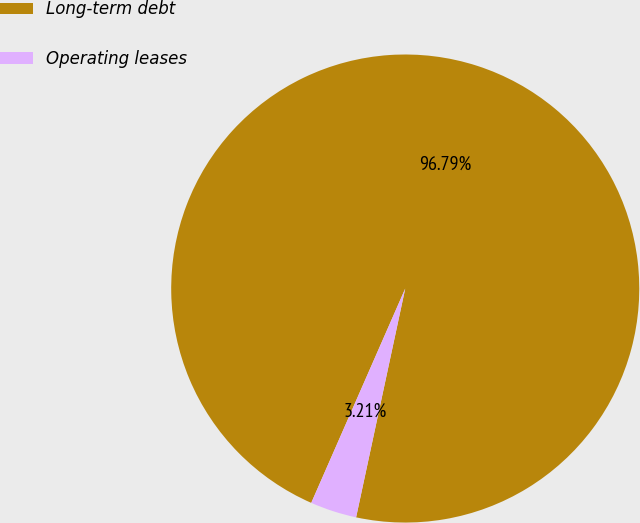Convert chart. <chart><loc_0><loc_0><loc_500><loc_500><pie_chart><fcel>Long-term debt<fcel>Operating leases<nl><fcel>96.79%<fcel>3.21%<nl></chart> 